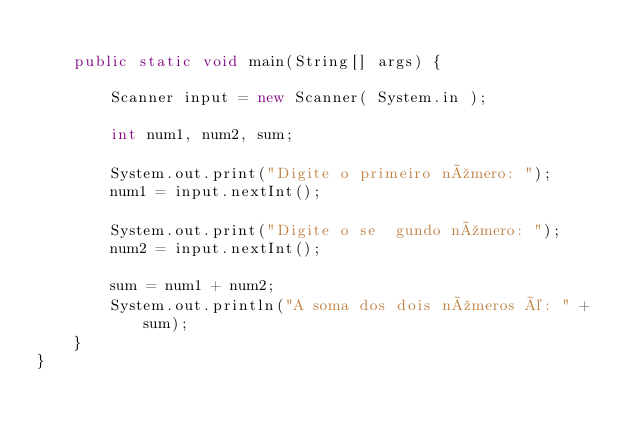<code> <loc_0><loc_0><loc_500><loc_500><_Java_>
    public static void main(String[] args) {

        Scanner input = new Scanner( System.in );

        int num1, num2, sum;

        System.out.print("Digite o primeiro número: ");
        num1 = input.nextInt();

        System.out.print("Digite o se  gundo número: ");
        num2 = input.nextInt();

        sum = num1 + num2;
        System.out.println("A soma dos dois números é: " + sum);
    }
}
</code> 